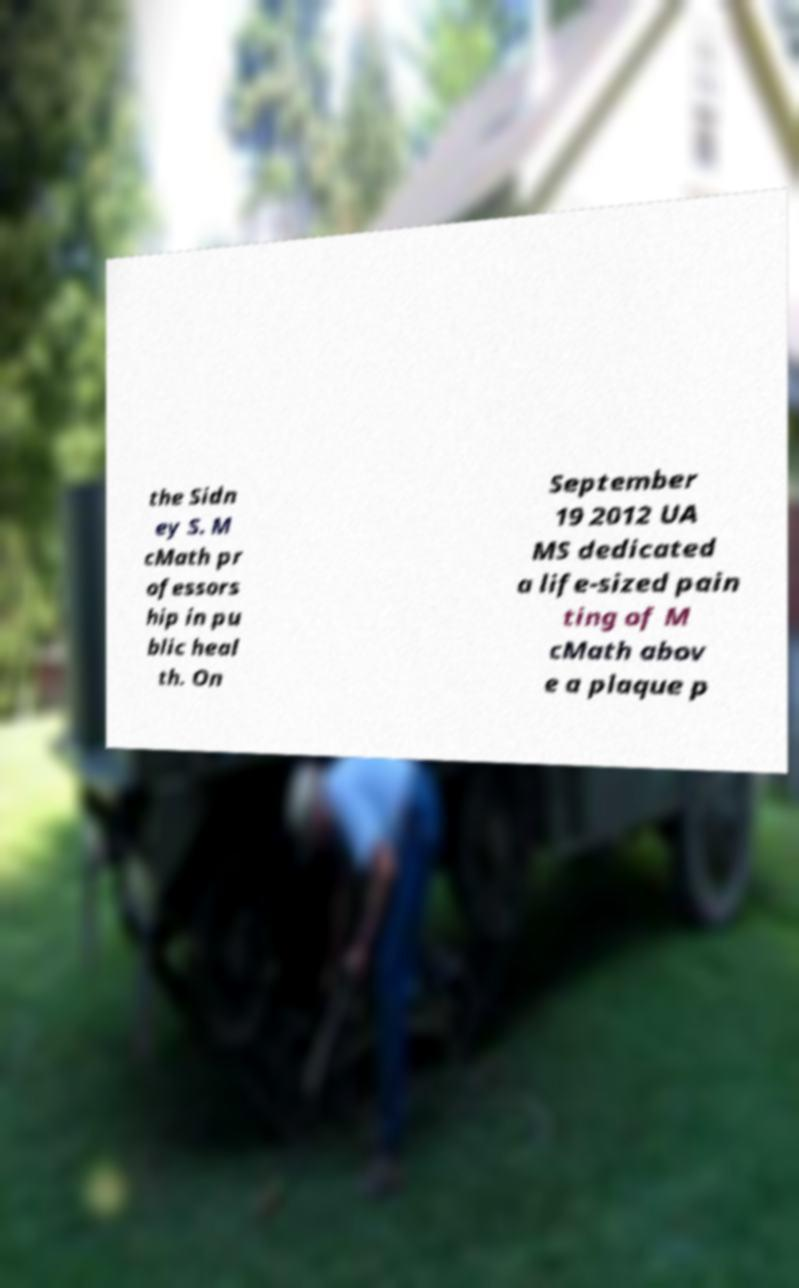Please read and relay the text visible in this image. What does it say? the Sidn ey S. M cMath pr ofessors hip in pu blic heal th. On September 19 2012 UA MS dedicated a life-sized pain ting of M cMath abov e a plaque p 